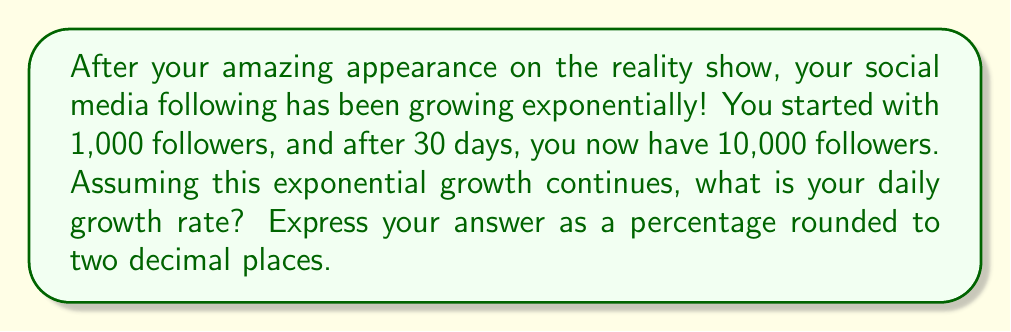Help me with this question. Let's approach this step-by-step using the exponential growth formula:

1) The exponential growth formula is:
   $$A = P(1 + r)^t$$
   Where:
   $A$ = Final amount
   $P$ = Initial amount
   $r$ = Daily growth rate (in decimal form)
   $t$ = Number of days

2) We know:
   $A = 10,000$ (final followers)
   $P = 1,000$ (initial followers)
   $t = 30$ (days)

3) Let's substitute these values into the formula:
   $$10,000 = 1,000(1 + r)^{30}$$

4) Divide both sides by 1,000:
   $$10 = (1 + r)^{30}$$

5) Take the 30th root of both sides:
   $$\sqrt[30]{10} = 1 + r$$

6) Subtract 1 from both sides:
   $$\sqrt[30]{10} - 1 = r$$

7) Calculate this value:
   $$r \approx 0.0777$$

8) Convert to a percentage by multiplying by 100:
   $$0.0777 \times 100 \approx 7.77\%$$

Therefore, the daily growth rate is approximately 7.77%.
Answer: 7.77% 